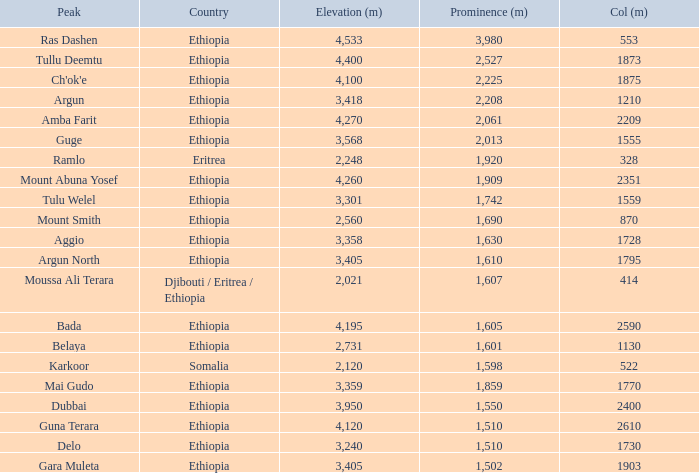Given a col height of 1,728 meters and an elevation not exceeding 3,358 meters, what is the total prominence value in meters for ethiopia? 0.0. 